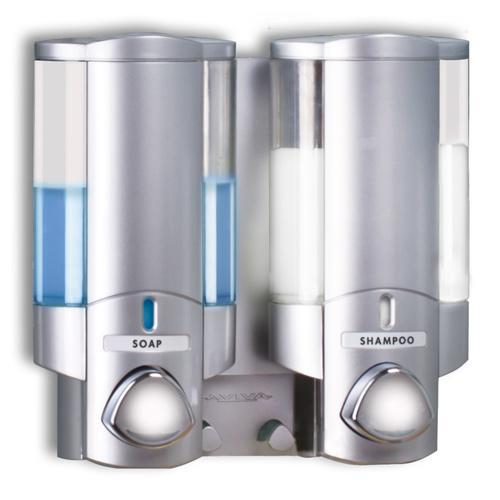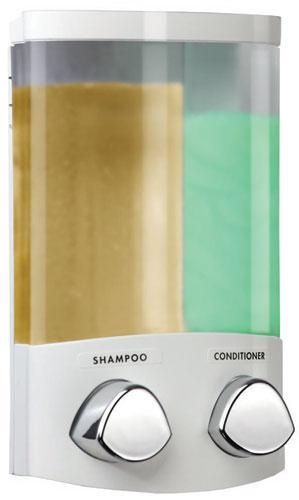The first image is the image on the left, the second image is the image on the right. Considering the images on both sides, is "The right image shows a soap dispenser that has both yellow and green liquid visible in separate compartments" valid? Answer yes or no. Yes. The first image is the image on the left, the second image is the image on the right. Analyze the images presented: Is the assertion "At least one dispenser is filled with a colored, non-white substance and dispenses more than one substance." valid? Answer yes or no. Yes. 